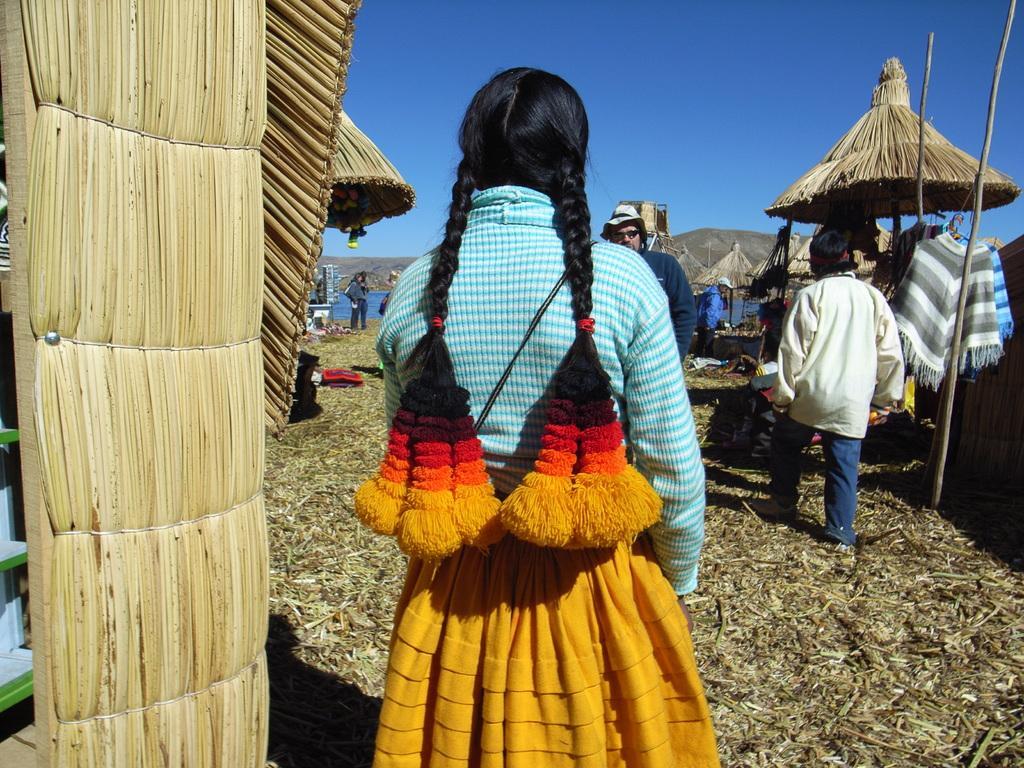How would you summarize this image in a sentence or two? In this picture I can see there is a girl standing here and she is wearing a shirt and a skirt. She is also wearing hangings to her hair and there is a wall on to left side and there are few people in the backdrop, there is a man wearing goggles and a hat. In the backdrop there is a mountain and the sky is clear. 